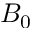<formula> <loc_0><loc_0><loc_500><loc_500>B _ { 0 }</formula> 